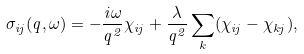<formula> <loc_0><loc_0><loc_500><loc_500>\sigma _ { i j } ( { q } , \omega ) = - \frac { i \omega } { q ^ { 2 } } \chi _ { i j } + \frac { \lambda } { q ^ { 2 } } \sum _ { k } ( \chi _ { i j } - \chi _ { k j } ) ,</formula> 